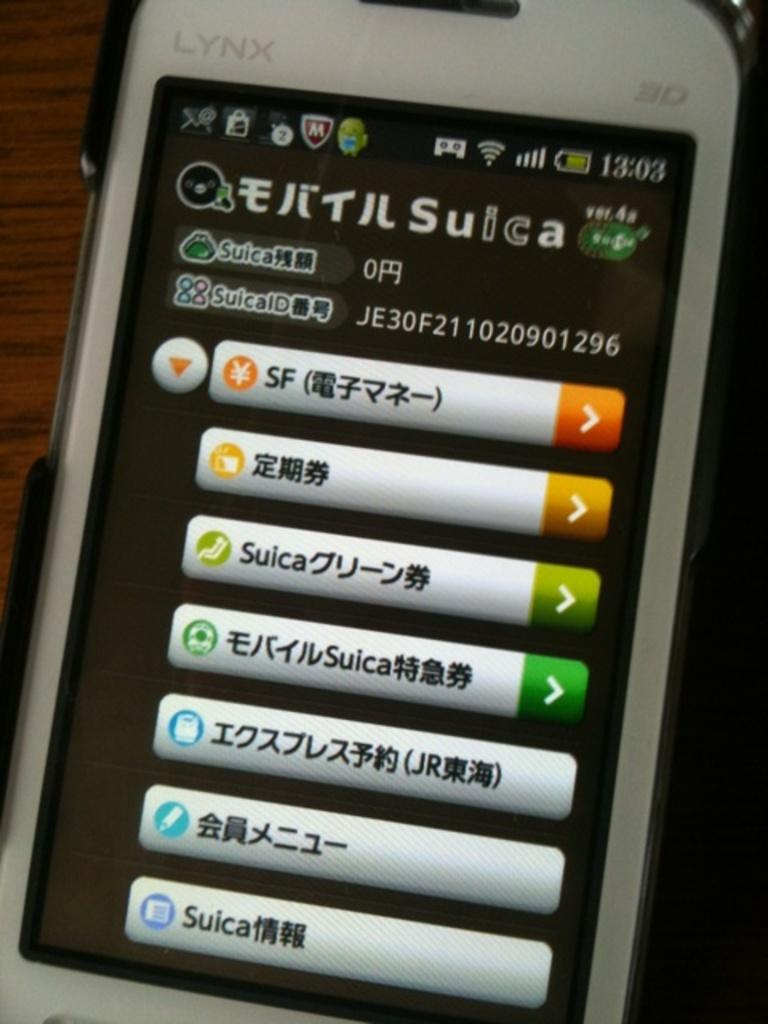<image>
Give a short and clear explanation of the subsequent image. A Lynx phone displays that the time is 13:03. 